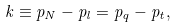<formula> <loc_0><loc_0><loc_500><loc_500>k \equiv p _ { N } - p _ { l } = p _ { q } - p _ { t } ,</formula> 